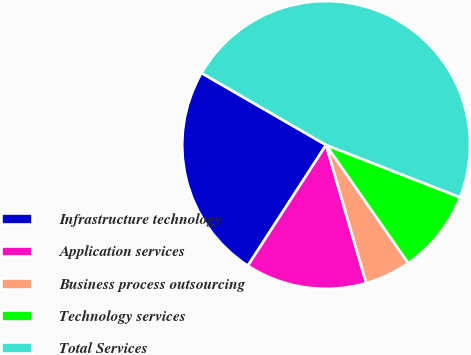Convert chart to OTSL. <chart><loc_0><loc_0><loc_500><loc_500><pie_chart><fcel>Infrastructure technology<fcel>Application services<fcel>Business process outsourcing<fcel>Technology services<fcel>Total Services<nl><fcel>24.18%<fcel>13.65%<fcel>5.17%<fcel>9.41%<fcel>47.58%<nl></chart> 